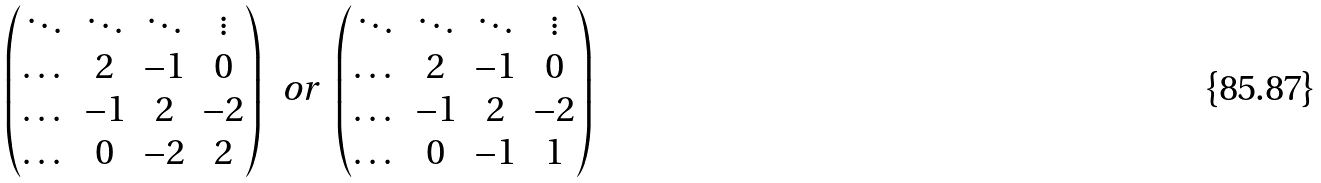<formula> <loc_0><loc_0><loc_500><loc_500>\begin{pmatrix} \ddots & \ddots & \ddots & \vdots \\ \dots & 2 & - 1 & 0 \\ \dots & - 1 & 2 & - 2 \\ \dots & 0 & - 2 & 2 \end{pmatrix} \, \text { or } \, \begin{pmatrix} \ddots & \ddots & \ddots & \vdots \\ \dots & 2 & - 1 & 0 \\ \dots & - 1 & 2 & - 2 \\ \dots & 0 & - 1 & 1 \end{pmatrix}</formula> 